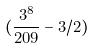Convert formula to latex. <formula><loc_0><loc_0><loc_500><loc_500>( \frac { 3 ^ { 8 } } { 2 0 9 } - 3 / 2 )</formula> 